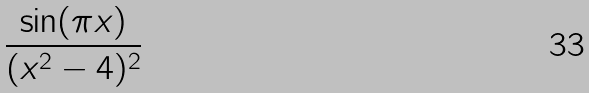<formula> <loc_0><loc_0><loc_500><loc_500>\frac { \sin ( \pi x ) } { ( x ^ { 2 } - 4 ) ^ { 2 } }</formula> 